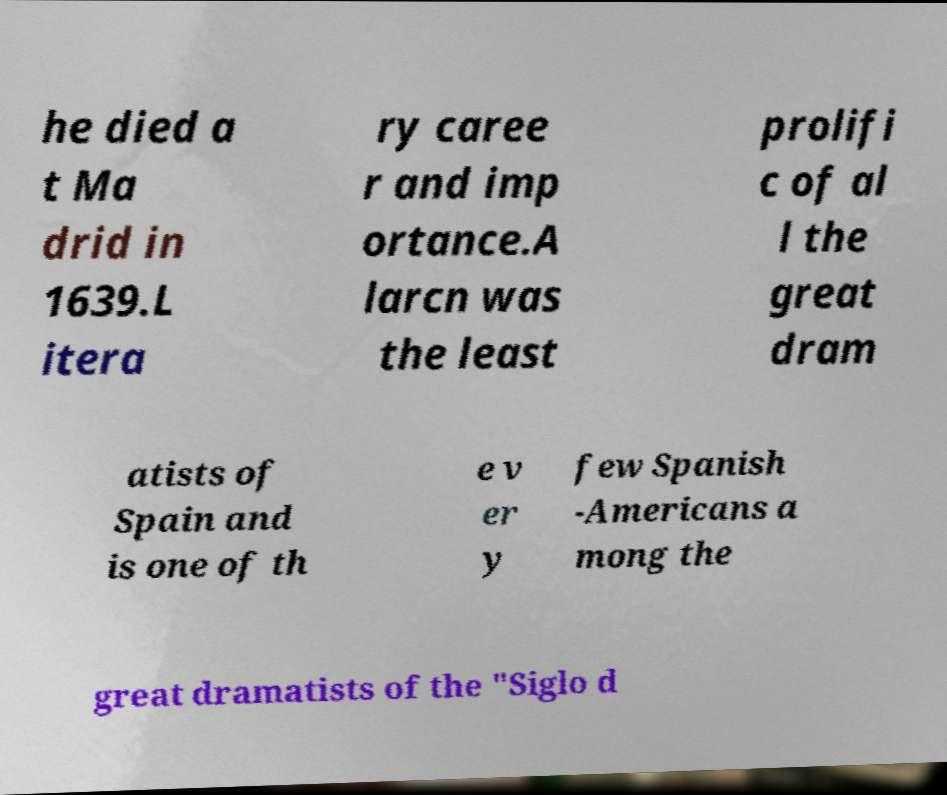For documentation purposes, I need the text within this image transcribed. Could you provide that? he died a t Ma drid in 1639.L itera ry caree r and imp ortance.A larcn was the least prolifi c of al l the great dram atists of Spain and is one of th e v er y few Spanish -Americans a mong the great dramatists of the "Siglo d 